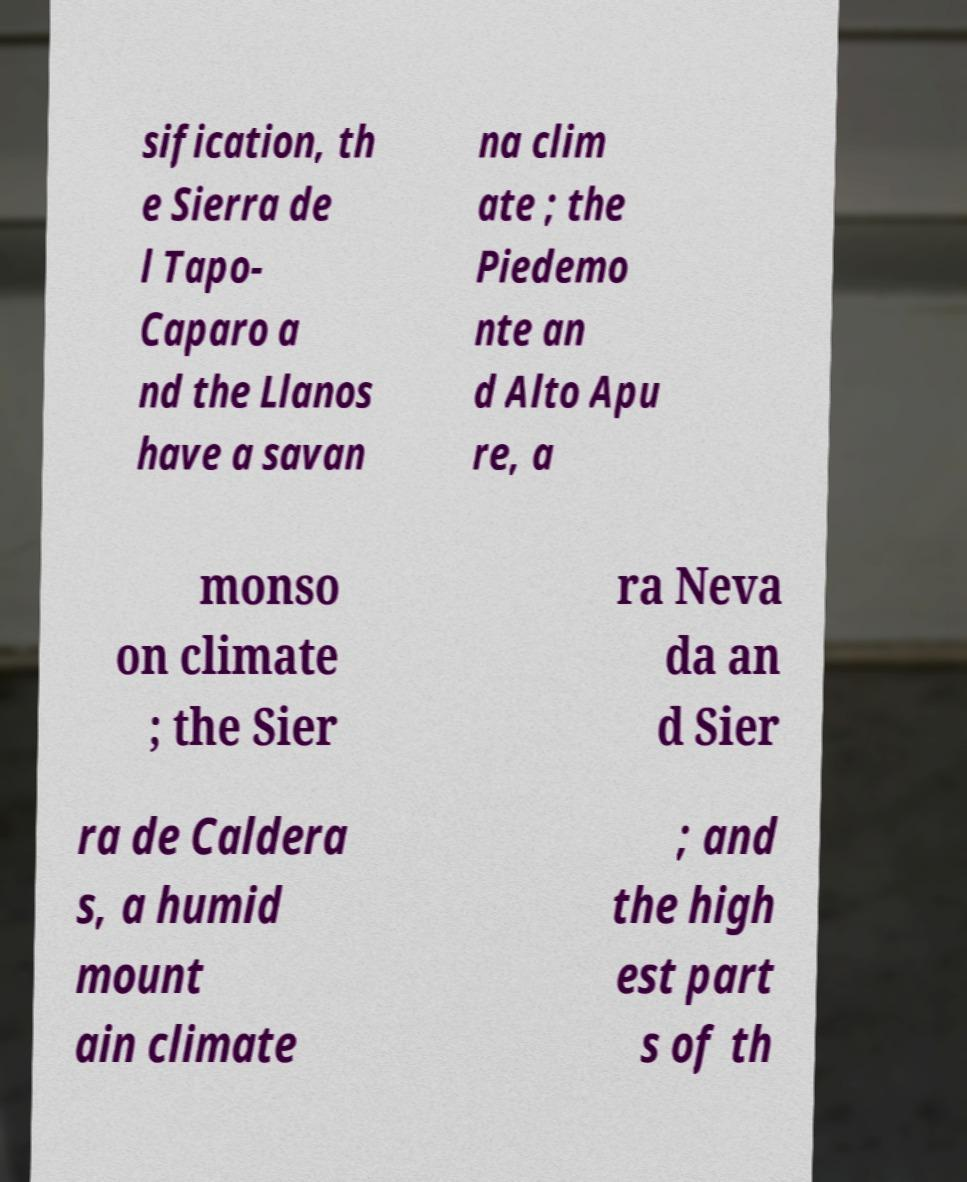Could you assist in decoding the text presented in this image and type it out clearly? sification, th e Sierra de l Tapo- Caparo a nd the Llanos have a savan na clim ate ; the Piedemo nte an d Alto Apu re, a monso on climate ; the Sier ra Neva da an d Sier ra de Caldera s, a humid mount ain climate ; and the high est part s of th 